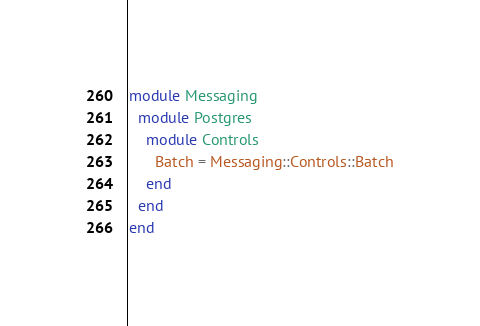<code> <loc_0><loc_0><loc_500><loc_500><_Ruby_>module Messaging
  module Postgres
    module Controls
      Batch = Messaging::Controls::Batch
    end
  end
end
</code> 